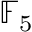Convert formula to latex. <formula><loc_0><loc_0><loc_500><loc_500>\mathbb { F } _ { 5 }</formula> 